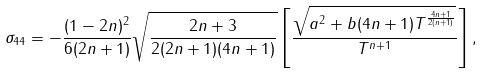Convert formula to latex. <formula><loc_0><loc_0><loc_500><loc_500>\sigma _ { 4 4 } = - \frac { ( 1 - 2 n ) ^ { 2 } } { 6 ( 2 n + 1 ) } \sqrt { \frac { 2 n + 3 } { 2 ( 2 n + 1 ) ( 4 n + 1 ) } } \left [ \frac { \sqrt { a ^ { 2 } + b ( 4 n + 1 ) T ^ { \frac { 4 n + 1 } { 2 ( n + 1 ) } } } } { T ^ { n + 1 } } \right ] ,</formula> 